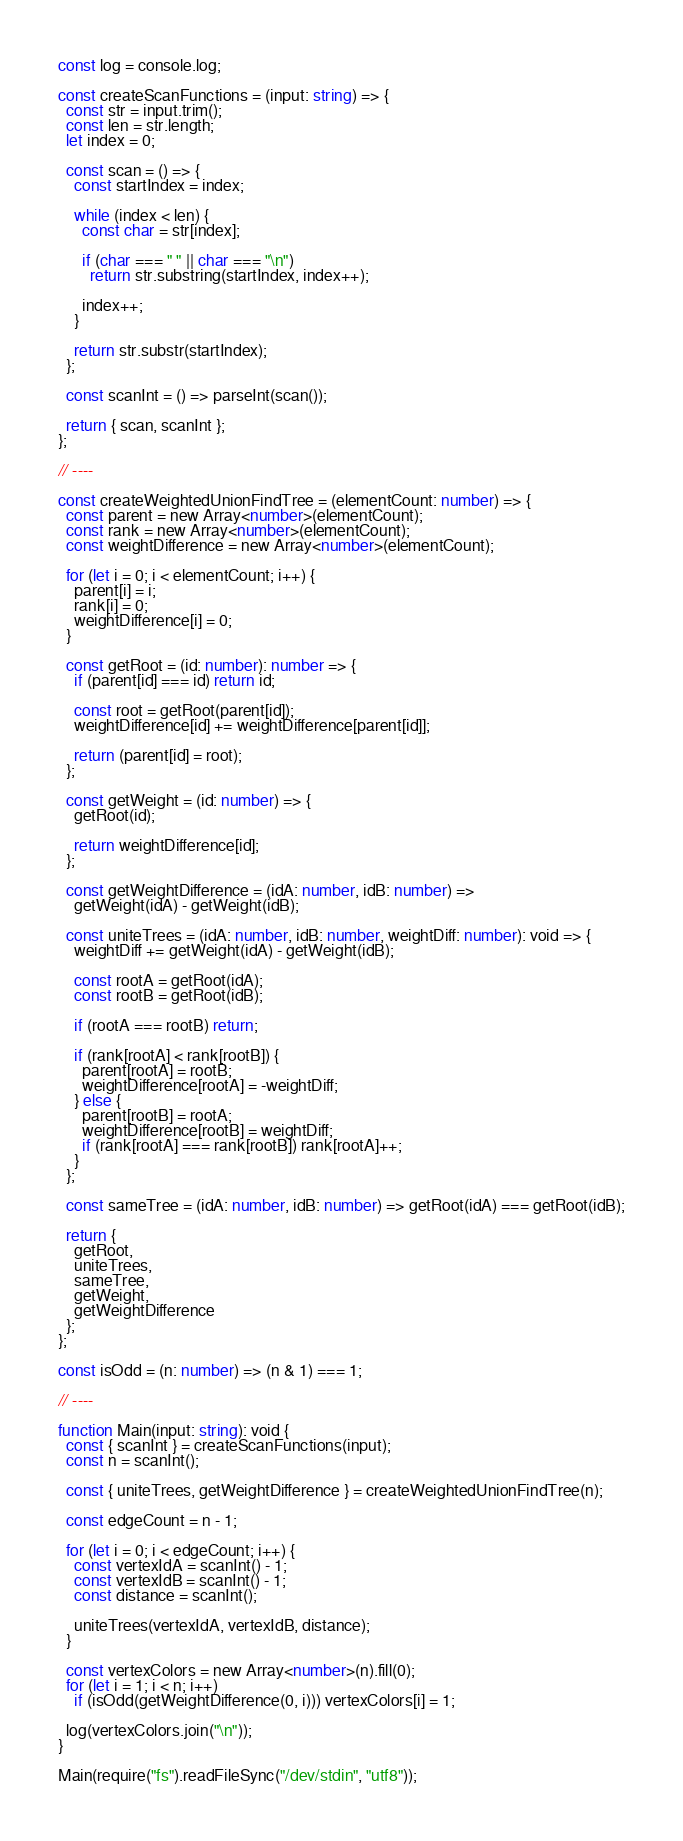<code> <loc_0><loc_0><loc_500><loc_500><_TypeScript_>const log = console.log;

const createScanFunctions = (input: string) => {
  const str = input.trim();
  const len = str.length;
  let index = 0;

  const scan = () => {
    const startIndex = index;

    while (index < len) {
      const char = str[index];

      if (char === " " || char === "\n")
        return str.substring(startIndex, index++);

      index++;
    }

    return str.substr(startIndex);
  };

  const scanInt = () => parseInt(scan());

  return { scan, scanInt };
};

// ----

const createWeightedUnionFindTree = (elementCount: number) => {
  const parent = new Array<number>(elementCount);
  const rank = new Array<number>(elementCount);
  const weightDifference = new Array<number>(elementCount);

  for (let i = 0; i < elementCount; i++) {
    parent[i] = i;
    rank[i] = 0;
    weightDifference[i] = 0;
  }

  const getRoot = (id: number): number => {
    if (parent[id] === id) return id;

    const root = getRoot(parent[id]);
    weightDifference[id] += weightDifference[parent[id]];

    return (parent[id] = root);
  };

  const getWeight = (id: number) => {
    getRoot(id);

    return weightDifference[id];
  };

  const getWeightDifference = (idA: number, idB: number) =>
    getWeight(idA) - getWeight(idB);

  const uniteTrees = (idA: number, idB: number, weightDiff: number): void => {
    weightDiff += getWeight(idA) - getWeight(idB);

    const rootA = getRoot(idA);
    const rootB = getRoot(idB);

    if (rootA === rootB) return;

    if (rank[rootA] < rank[rootB]) {
      parent[rootA] = rootB;
      weightDifference[rootA] = -weightDiff;
    } else {
      parent[rootB] = rootA;
      weightDifference[rootB] = weightDiff;
      if (rank[rootA] === rank[rootB]) rank[rootA]++;
    }
  };

  const sameTree = (idA: number, idB: number) => getRoot(idA) === getRoot(idB);

  return {
    getRoot,
    uniteTrees,
    sameTree,
    getWeight,
    getWeightDifference
  };
};

const isOdd = (n: number) => (n & 1) === 1;

// ----

function Main(input: string): void {
  const { scanInt } = createScanFunctions(input);
  const n = scanInt();

  const { uniteTrees, getWeightDifference } = createWeightedUnionFindTree(n);

  const edgeCount = n - 1;

  for (let i = 0; i < edgeCount; i++) {
    const vertexIdA = scanInt() - 1;
    const vertexIdB = scanInt() - 1;
    const distance = scanInt();

    uniteTrees(vertexIdA, vertexIdB, distance);
  }

  const vertexColors = new Array<number>(n).fill(0);
  for (let i = 1; i < n; i++)
    if (isOdd(getWeightDifference(0, i))) vertexColors[i] = 1;

  log(vertexColors.join("\n"));
}

Main(require("fs").readFileSync("/dev/stdin", "utf8"));
</code> 